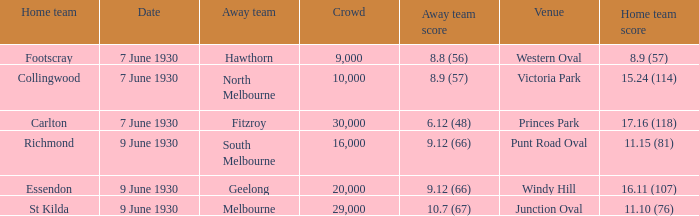9 (57)? Victoria Park. 